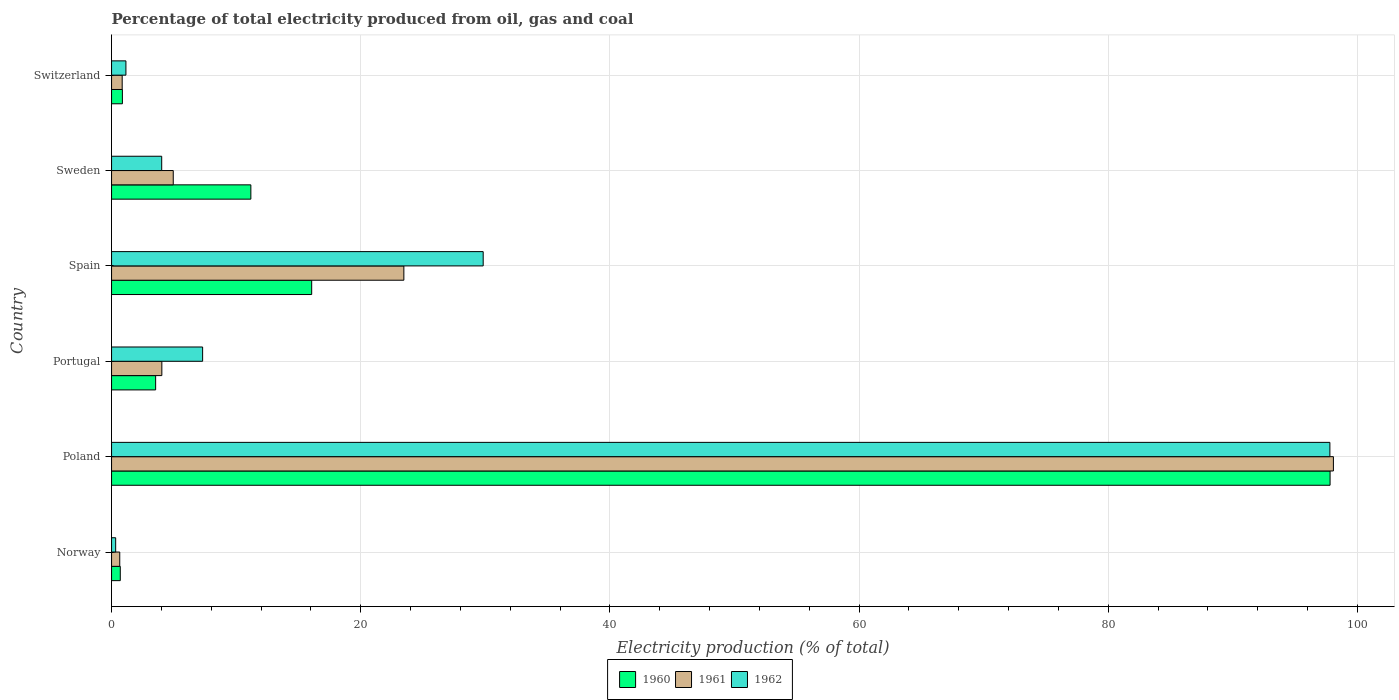Are the number of bars on each tick of the Y-axis equal?
Provide a short and direct response. Yes. How many bars are there on the 5th tick from the bottom?
Your answer should be very brief. 3. What is the label of the 2nd group of bars from the top?
Provide a short and direct response. Sweden. In how many cases, is the number of bars for a given country not equal to the number of legend labels?
Your answer should be compact. 0. What is the electricity production in in 1962 in Norway?
Provide a succinct answer. 0.33. Across all countries, what is the maximum electricity production in in 1961?
Keep it short and to the point. 98.07. Across all countries, what is the minimum electricity production in in 1960?
Your answer should be very brief. 0.7. In which country was the electricity production in in 1960 minimum?
Provide a succinct answer. Norway. What is the total electricity production in in 1962 in the graph?
Your answer should be very brief. 140.43. What is the difference between the electricity production in in 1962 in Sweden and that in Switzerland?
Your answer should be compact. 2.87. What is the difference between the electricity production in in 1962 in Switzerland and the electricity production in in 1960 in Portugal?
Provide a short and direct response. -2.38. What is the average electricity production in in 1962 per country?
Ensure brevity in your answer.  23.41. What is the difference between the electricity production in in 1961 and electricity production in in 1960 in Sweden?
Your answer should be very brief. -6.23. What is the ratio of the electricity production in in 1961 in Norway to that in Spain?
Provide a succinct answer. 0.03. Is the electricity production in in 1961 in Norway less than that in Spain?
Provide a short and direct response. Yes. What is the difference between the highest and the second highest electricity production in in 1960?
Your answer should be compact. 81.74. What is the difference between the highest and the lowest electricity production in in 1961?
Offer a very short reply. 97.41. In how many countries, is the electricity production in in 1961 greater than the average electricity production in in 1961 taken over all countries?
Offer a terse response. 2. Is the sum of the electricity production in in 1961 in Portugal and Sweden greater than the maximum electricity production in in 1960 across all countries?
Your response must be concise. No. Is it the case that in every country, the sum of the electricity production in in 1961 and electricity production in in 1962 is greater than the electricity production in in 1960?
Offer a very short reply. No. How many bars are there?
Provide a short and direct response. 18. How many countries are there in the graph?
Give a very brief answer. 6. What is the difference between two consecutive major ticks on the X-axis?
Ensure brevity in your answer.  20. How are the legend labels stacked?
Keep it short and to the point. Horizontal. What is the title of the graph?
Your response must be concise. Percentage of total electricity produced from oil, gas and coal. Does "1961" appear as one of the legend labels in the graph?
Offer a terse response. Yes. What is the label or title of the X-axis?
Your answer should be very brief. Electricity production (% of total). What is the Electricity production (% of total) of 1960 in Norway?
Give a very brief answer. 0.7. What is the Electricity production (% of total) in 1961 in Norway?
Provide a succinct answer. 0.66. What is the Electricity production (% of total) of 1962 in Norway?
Your answer should be very brief. 0.33. What is the Electricity production (% of total) in 1960 in Poland?
Give a very brief answer. 97.8. What is the Electricity production (% of total) of 1961 in Poland?
Your response must be concise. 98.07. What is the Electricity production (% of total) in 1962 in Poland?
Offer a terse response. 97.79. What is the Electricity production (% of total) of 1960 in Portugal?
Offer a very short reply. 3.54. What is the Electricity production (% of total) in 1961 in Portugal?
Keep it short and to the point. 4.04. What is the Electricity production (% of total) in 1962 in Portugal?
Your answer should be very brief. 7.31. What is the Electricity production (% of total) of 1960 in Spain?
Provide a short and direct response. 16.06. What is the Electricity production (% of total) of 1961 in Spain?
Your answer should be very brief. 23.46. What is the Electricity production (% of total) in 1962 in Spain?
Keep it short and to the point. 29.83. What is the Electricity production (% of total) in 1960 in Sweden?
Make the answer very short. 11.18. What is the Electricity production (% of total) in 1961 in Sweden?
Offer a terse response. 4.95. What is the Electricity production (% of total) of 1962 in Sweden?
Offer a terse response. 4.02. What is the Electricity production (% of total) of 1960 in Switzerland?
Your response must be concise. 0.87. What is the Electricity production (% of total) of 1961 in Switzerland?
Ensure brevity in your answer.  0.85. What is the Electricity production (% of total) of 1962 in Switzerland?
Keep it short and to the point. 1.15. Across all countries, what is the maximum Electricity production (% of total) in 1960?
Offer a very short reply. 97.8. Across all countries, what is the maximum Electricity production (% of total) in 1961?
Your answer should be compact. 98.07. Across all countries, what is the maximum Electricity production (% of total) in 1962?
Your response must be concise. 97.79. Across all countries, what is the minimum Electricity production (% of total) in 1960?
Ensure brevity in your answer.  0.7. Across all countries, what is the minimum Electricity production (% of total) of 1961?
Provide a succinct answer. 0.66. Across all countries, what is the minimum Electricity production (% of total) of 1962?
Your answer should be very brief. 0.33. What is the total Electricity production (% of total) of 1960 in the graph?
Offer a terse response. 130.15. What is the total Electricity production (% of total) in 1961 in the graph?
Keep it short and to the point. 132.03. What is the total Electricity production (% of total) of 1962 in the graph?
Provide a succinct answer. 140.43. What is the difference between the Electricity production (% of total) of 1960 in Norway and that in Poland?
Give a very brief answer. -97.1. What is the difference between the Electricity production (% of total) in 1961 in Norway and that in Poland?
Offer a terse response. -97.41. What is the difference between the Electricity production (% of total) in 1962 in Norway and that in Poland?
Keep it short and to the point. -97.46. What is the difference between the Electricity production (% of total) in 1960 in Norway and that in Portugal?
Your answer should be very brief. -2.84. What is the difference between the Electricity production (% of total) in 1961 in Norway and that in Portugal?
Your answer should be very brief. -3.38. What is the difference between the Electricity production (% of total) in 1962 in Norway and that in Portugal?
Provide a succinct answer. -6.98. What is the difference between the Electricity production (% of total) of 1960 in Norway and that in Spain?
Your answer should be very brief. -15.36. What is the difference between the Electricity production (% of total) in 1961 in Norway and that in Spain?
Provide a short and direct response. -22.8. What is the difference between the Electricity production (% of total) of 1962 in Norway and that in Spain?
Provide a short and direct response. -29.5. What is the difference between the Electricity production (% of total) in 1960 in Norway and that in Sweden?
Your answer should be compact. -10.48. What is the difference between the Electricity production (% of total) of 1961 in Norway and that in Sweden?
Your response must be concise. -4.29. What is the difference between the Electricity production (% of total) of 1962 in Norway and that in Sweden?
Your answer should be very brief. -3.69. What is the difference between the Electricity production (% of total) in 1960 in Norway and that in Switzerland?
Keep it short and to the point. -0.17. What is the difference between the Electricity production (% of total) of 1961 in Norway and that in Switzerland?
Make the answer very short. -0.2. What is the difference between the Electricity production (% of total) in 1962 in Norway and that in Switzerland?
Provide a succinct answer. -0.82. What is the difference between the Electricity production (% of total) of 1960 in Poland and that in Portugal?
Make the answer very short. 94.26. What is the difference between the Electricity production (% of total) in 1961 in Poland and that in Portugal?
Give a very brief answer. 94.03. What is the difference between the Electricity production (% of total) in 1962 in Poland and that in Portugal?
Provide a succinct answer. 90.48. What is the difference between the Electricity production (% of total) in 1960 in Poland and that in Spain?
Provide a succinct answer. 81.74. What is the difference between the Electricity production (% of total) of 1961 in Poland and that in Spain?
Ensure brevity in your answer.  74.61. What is the difference between the Electricity production (% of total) in 1962 in Poland and that in Spain?
Provide a short and direct response. 67.96. What is the difference between the Electricity production (% of total) of 1960 in Poland and that in Sweden?
Make the answer very short. 86.62. What is the difference between the Electricity production (% of total) in 1961 in Poland and that in Sweden?
Your response must be concise. 93.12. What is the difference between the Electricity production (% of total) in 1962 in Poland and that in Sweden?
Your response must be concise. 93.76. What is the difference between the Electricity production (% of total) of 1960 in Poland and that in Switzerland?
Offer a terse response. 96.93. What is the difference between the Electricity production (% of total) in 1961 in Poland and that in Switzerland?
Your response must be concise. 97.21. What is the difference between the Electricity production (% of total) of 1962 in Poland and that in Switzerland?
Your answer should be very brief. 96.63. What is the difference between the Electricity production (% of total) of 1960 in Portugal and that in Spain?
Offer a terse response. -12.53. What is the difference between the Electricity production (% of total) in 1961 in Portugal and that in Spain?
Offer a terse response. -19.42. What is the difference between the Electricity production (% of total) in 1962 in Portugal and that in Spain?
Your response must be concise. -22.52. What is the difference between the Electricity production (% of total) of 1960 in Portugal and that in Sweden?
Your answer should be very brief. -7.64. What is the difference between the Electricity production (% of total) of 1961 in Portugal and that in Sweden?
Provide a short and direct response. -0.92. What is the difference between the Electricity production (% of total) in 1962 in Portugal and that in Sweden?
Ensure brevity in your answer.  3.28. What is the difference between the Electricity production (% of total) in 1960 in Portugal and that in Switzerland?
Offer a terse response. 2.67. What is the difference between the Electricity production (% of total) of 1961 in Portugal and that in Switzerland?
Give a very brief answer. 3.18. What is the difference between the Electricity production (% of total) in 1962 in Portugal and that in Switzerland?
Your response must be concise. 6.16. What is the difference between the Electricity production (% of total) of 1960 in Spain and that in Sweden?
Offer a very short reply. 4.88. What is the difference between the Electricity production (% of total) in 1961 in Spain and that in Sweden?
Your answer should be very brief. 18.51. What is the difference between the Electricity production (% of total) in 1962 in Spain and that in Sweden?
Give a very brief answer. 25.8. What is the difference between the Electricity production (% of total) of 1960 in Spain and that in Switzerland?
Make the answer very short. 15.19. What is the difference between the Electricity production (% of total) in 1961 in Spain and that in Switzerland?
Give a very brief answer. 22.61. What is the difference between the Electricity production (% of total) of 1962 in Spain and that in Switzerland?
Your answer should be very brief. 28.67. What is the difference between the Electricity production (% of total) of 1960 in Sweden and that in Switzerland?
Make the answer very short. 10.31. What is the difference between the Electricity production (% of total) of 1961 in Sweden and that in Switzerland?
Provide a short and direct response. 4.1. What is the difference between the Electricity production (% of total) of 1962 in Sweden and that in Switzerland?
Provide a succinct answer. 2.87. What is the difference between the Electricity production (% of total) in 1960 in Norway and the Electricity production (% of total) in 1961 in Poland?
Give a very brief answer. -97.37. What is the difference between the Electricity production (% of total) of 1960 in Norway and the Electricity production (% of total) of 1962 in Poland?
Offer a terse response. -97.09. What is the difference between the Electricity production (% of total) of 1961 in Norway and the Electricity production (% of total) of 1962 in Poland?
Give a very brief answer. -97.13. What is the difference between the Electricity production (% of total) in 1960 in Norway and the Electricity production (% of total) in 1961 in Portugal?
Ensure brevity in your answer.  -3.34. What is the difference between the Electricity production (% of total) in 1960 in Norway and the Electricity production (% of total) in 1962 in Portugal?
Provide a short and direct response. -6.61. What is the difference between the Electricity production (% of total) of 1961 in Norway and the Electricity production (% of total) of 1962 in Portugal?
Your answer should be very brief. -6.65. What is the difference between the Electricity production (% of total) of 1960 in Norway and the Electricity production (% of total) of 1961 in Spain?
Provide a short and direct response. -22.76. What is the difference between the Electricity production (% of total) in 1960 in Norway and the Electricity production (% of total) in 1962 in Spain?
Offer a very short reply. -29.13. What is the difference between the Electricity production (% of total) in 1961 in Norway and the Electricity production (% of total) in 1962 in Spain?
Make the answer very short. -29.17. What is the difference between the Electricity production (% of total) of 1960 in Norway and the Electricity production (% of total) of 1961 in Sweden?
Offer a very short reply. -4.25. What is the difference between the Electricity production (% of total) in 1960 in Norway and the Electricity production (% of total) in 1962 in Sweden?
Your response must be concise. -3.33. What is the difference between the Electricity production (% of total) in 1961 in Norway and the Electricity production (% of total) in 1962 in Sweden?
Ensure brevity in your answer.  -3.37. What is the difference between the Electricity production (% of total) in 1960 in Norway and the Electricity production (% of total) in 1961 in Switzerland?
Give a very brief answer. -0.15. What is the difference between the Electricity production (% of total) in 1960 in Norway and the Electricity production (% of total) in 1962 in Switzerland?
Your answer should be very brief. -0.45. What is the difference between the Electricity production (% of total) in 1961 in Norway and the Electricity production (% of total) in 1962 in Switzerland?
Your answer should be very brief. -0.5. What is the difference between the Electricity production (% of total) of 1960 in Poland and the Electricity production (% of total) of 1961 in Portugal?
Keep it short and to the point. 93.76. What is the difference between the Electricity production (% of total) in 1960 in Poland and the Electricity production (% of total) in 1962 in Portugal?
Your answer should be very brief. 90.49. What is the difference between the Electricity production (% of total) in 1961 in Poland and the Electricity production (% of total) in 1962 in Portugal?
Give a very brief answer. 90.76. What is the difference between the Electricity production (% of total) in 1960 in Poland and the Electricity production (% of total) in 1961 in Spain?
Provide a succinct answer. 74.34. What is the difference between the Electricity production (% of total) of 1960 in Poland and the Electricity production (% of total) of 1962 in Spain?
Give a very brief answer. 67.97. What is the difference between the Electricity production (% of total) in 1961 in Poland and the Electricity production (% of total) in 1962 in Spain?
Your answer should be very brief. 68.24. What is the difference between the Electricity production (% of total) of 1960 in Poland and the Electricity production (% of total) of 1961 in Sweden?
Offer a very short reply. 92.85. What is the difference between the Electricity production (% of total) in 1960 in Poland and the Electricity production (% of total) in 1962 in Sweden?
Offer a very short reply. 93.78. What is the difference between the Electricity production (% of total) in 1961 in Poland and the Electricity production (% of total) in 1962 in Sweden?
Your response must be concise. 94.04. What is the difference between the Electricity production (% of total) of 1960 in Poland and the Electricity production (% of total) of 1961 in Switzerland?
Give a very brief answer. 96.95. What is the difference between the Electricity production (% of total) of 1960 in Poland and the Electricity production (% of total) of 1962 in Switzerland?
Give a very brief answer. 96.65. What is the difference between the Electricity production (% of total) in 1961 in Poland and the Electricity production (% of total) in 1962 in Switzerland?
Give a very brief answer. 96.91. What is the difference between the Electricity production (% of total) in 1960 in Portugal and the Electricity production (% of total) in 1961 in Spain?
Provide a succinct answer. -19.92. What is the difference between the Electricity production (% of total) in 1960 in Portugal and the Electricity production (% of total) in 1962 in Spain?
Provide a succinct answer. -26.29. What is the difference between the Electricity production (% of total) of 1961 in Portugal and the Electricity production (% of total) of 1962 in Spain?
Offer a terse response. -25.79. What is the difference between the Electricity production (% of total) in 1960 in Portugal and the Electricity production (% of total) in 1961 in Sweden?
Make the answer very short. -1.41. What is the difference between the Electricity production (% of total) of 1960 in Portugal and the Electricity production (% of total) of 1962 in Sweden?
Provide a succinct answer. -0.49. What is the difference between the Electricity production (% of total) in 1961 in Portugal and the Electricity production (% of total) in 1962 in Sweden?
Provide a succinct answer. 0.01. What is the difference between the Electricity production (% of total) in 1960 in Portugal and the Electricity production (% of total) in 1961 in Switzerland?
Keep it short and to the point. 2.68. What is the difference between the Electricity production (% of total) in 1960 in Portugal and the Electricity production (% of total) in 1962 in Switzerland?
Provide a short and direct response. 2.38. What is the difference between the Electricity production (% of total) in 1961 in Portugal and the Electricity production (% of total) in 1962 in Switzerland?
Give a very brief answer. 2.88. What is the difference between the Electricity production (% of total) in 1960 in Spain and the Electricity production (% of total) in 1961 in Sweden?
Your response must be concise. 11.11. What is the difference between the Electricity production (% of total) in 1960 in Spain and the Electricity production (% of total) in 1962 in Sweden?
Your answer should be compact. 12.04. What is the difference between the Electricity production (% of total) of 1961 in Spain and the Electricity production (% of total) of 1962 in Sweden?
Offer a very short reply. 19.44. What is the difference between the Electricity production (% of total) in 1960 in Spain and the Electricity production (% of total) in 1961 in Switzerland?
Make the answer very short. 15.21. What is the difference between the Electricity production (% of total) of 1960 in Spain and the Electricity production (% of total) of 1962 in Switzerland?
Make the answer very short. 14.91. What is the difference between the Electricity production (% of total) of 1961 in Spain and the Electricity production (% of total) of 1962 in Switzerland?
Your answer should be very brief. 22.31. What is the difference between the Electricity production (% of total) in 1960 in Sweden and the Electricity production (% of total) in 1961 in Switzerland?
Your answer should be very brief. 10.33. What is the difference between the Electricity production (% of total) of 1960 in Sweden and the Electricity production (% of total) of 1962 in Switzerland?
Make the answer very short. 10.03. What is the difference between the Electricity production (% of total) in 1961 in Sweden and the Electricity production (% of total) in 1962 in Switzerland?
Keep it short and to the point. 3.8. What is the average Electricity production (% of total) in 1960 per country?
Keep it short and to the point. 21.69. What is the average Electricity production (% of total) in 1961 per country?
Provide a short and direct response. 22. What is the average Electricity production (% of total) of 1962 per country?
Your response must be concise. 23.41. What is the difference between the Electricity production (% of total) in 1960 and Electricity production (% of total) in 1961 in Norway?
Your response must be concise. 0.04. What is the difference between the Electricity production (% of total) of 1960 and Electricity production (% of total) of 1962 in Norway?
Keep it short and to the point. 0.37. What is the difference between the Electricity production (% of total) of 1961 and Electricity production (% of total) of 1962 in Norway?
Ensure brevity in your answer.  0.33. What is the difference between the Electricity production (% of total) of 1960 and Electricity production (% of total) of 1961 in Poland?
Make the answer very short. -0.27. What is the difference between the Electricity production (% of total) of 1960 and Electricity production (% of total) of 1962 in Poland?
Offer a terse response. 0.01. What is the difference between the Electricity production (% of total) of 1961 and Electricity production (% of total) of 1962 in Poland?
Provide a short and direct response. 0.28. What is the difference between the Electricity production (% of total) of 1960 and Electricity production (% of total) of 1961 in Portugal?
Ensure brevity in your answer.  -0.5. What is the difference between the Electricity production (% of total) in 1960 and Electricity production (% of total) in 1962 in Portugal?
Your response must be concise. -3.77. What is the difference between the Electricity production (% of total) of 1961 and Electricity production (% of total) of 1962 in Portugal?
Your answer should be compact. -3.27. What is the difference between the Electricity production (% of total) in 1960 and Electricity production (% of total) in 1961 in Spain?
Provide a succinct answer. -7.4. What is the difference between the Electricity production (% of total) in 1960 and Electricity production (% of total) in 1962 in Spain?
Offer a terse response. -13.76. What is the difference between the Electricity production (% of total) of 1961 and Electricity production (% of total) of 1962 in Spain?
Offer a very short reply. -6.37. What is the difference between the Electricity production (% of total) of 1960 and Electricity production (% of total) of 1961 in Sweden?
Offer a very short reply. 6.23. What is the difference between the Electricity production (% of total) in 1960 and Electricity production (% of total) in 1962 in Sweden?
Your answer should be very brief. 7.16. What is the difference between the Electricity production (% of total) of 1961 and Electricity production (% of total) of 1962 in Sweden?
Your answer should be compact. 0.93. What is the difference between the Electricity production (% of total) in 1960 and Electricity production (% of total) in 1961 in Switzerland?
Keep it short and to the point. 0.02. What is the difference between the Electricity production (% of total) in 1960 and Electricity production (% of total) in 1962 in Switzerland?
Provide a succinct answer. -0.28. What is the difference between the Electricity production (% of total) of 1961 and Electricity production (% of total) of 1962 in Switzerland?
Your answer should be very brief. -0.3. What is the ratio of the Electricity production (% of total) in 1960 in Norway to that in Poland?
Provide a succinct answer. 0.01. What is the ratio of the Electricity production (% of total) of 1961 in Norway to that in Poland?
Ensure brevity in your answer.  0.01. What is the ratio of the Electricity production (% of total) in 1962 in Norway to that in Poland?
Give a very brief answer. 0. What is the ratio of the Electricity production (% of total) in 1960 in Norway to that in Portugal?
Offer a terse response. 0.2. What is the ratio of the Electricity production (% of total) in 1961 in Norway to that in Portugal?
Keep it short and to the point. 0.16. What is the ratio of the Electricity production (% of total) in 1962 in Norway to that in Portugal?
Offer a terse response. 0.05. What is the ratio of the Electricity production (% of total) of 1960 in Norway to that in Spain?
Make the answer very short. 0.04. What is the ratio of the Electricity production (% of total) in 1961 in Norway to that in Spain?
Provide a succinct answer. 0.03. What is the ratio of the Electricity production (% of total) in 1962 in Norway to that in Spain?
Your answer should be very brief. 0.01. What is the ratio of the Electricity production (% of total) of 1960 in Norway to that in Sweden?
Give a very brief answer. 0.06. What is the ratio of the Electricity production (% of total) of 1961 in Norway to that in Sweden?
Provide a short and direct response. 0.13. What is the ratio of the Electricity production (% of total) in 1962 in Norway to that in Sweden?
Your response must be concise. 0.08. What is the ratio of the Electricity production (% of total) of 1960 in Norway to that in Switzerland?
Your answer should be compact. 0.8. What is the ratio of the Electricity production (% of total) in 1961 in Norway to that in Switzerland?
Provide a short and direct response. 0.77. What is the ratio of the Electricity production (% of total) in 1962 in Norway to that in Switzerland?
Provide a succinct answer. 0.29. What is the ratio of the Electricity production (% of total) of 1960 in Poland to that in Portugal?
Your response must be concise. 27.65. What is the ratio of the Electricity production (% of total) of 1961 in Poland to that in Portugal?
Offer a very short reply. 24.3. What is the ratio of the Electricity production (% of total) of 1962 in Poland to that in Portugal?
Offer a terse response. 13.38. What is the ratio of the Electricity production (% of total) of 1960 in Poland to that in Spain?
Ensure brevity in your answer.  6.09. What is the ratio of the Electricity production (% of total) of 1961 in Poland to that in Spain?
Ensure brevity in your answer.  4.18. What is the ratio of the Electricity production (% of total) in 1962 in Poland to that in Spain?
Offer a terse response. 3.28. What is the ratio of the Electricity production (% of total) in 1960 in Poland to that in Sweden?
Provide a short and direct response. 8.75. What is the ratio of the Electricity production (% of total) in 1961 in Poland to that in Sweden?
Provide a short and direct response. 19.8. What is the ratio of the Electricity production (% of total) of 1962 in Poland to that in Sweden?
Your answer should be very brief. 24.3. What is the ratio of the Electricity production (% of total) of 1960 in Poland to that in Switzerland?
Provide a short and direct response. 112.47. What is the ratio of the Electricity production (% of total) in 1961 in Poland to that in Switzerland?
Ensure brevity in your answer.  114.89. What is the ratio of the Electricity production (% of total) in 1962 in Poland to that in Switzerland?
Offer a terse response. 84.78. What is the ratio of the Electricity production (% of total) in 1960 in Portugal to that in Spain?
Keep it short and to the point. 0.22. What is the ratio of the Electricity production (% of total) in 1961 in Portugal to that in Spain?
Offer a terse response. 0.17. What is the ratio of the Electricity production (% of total) in 1962 in Portugal to that in Spain?
Provide a short and direct response. 0.24. What is the ratio of the Electricity production (% of total) in 1960 in Portugal to that in Sweden?
Make the answer very short. 0.32. What is the ratio of the Electricity production (% of total) of 1961 in Portugal to that in Sweden?
Ensure brevity in your answer.  0.82. What is the ratio of the Electricity production (% of total) in 1962 in Portugal to that in Sweden?
Give a very brief answer. 1.82. What is the ratio of the Electricity production (% of total) in 1960 in Portugal to that in Switzerland?
Make the answer very short. 4.07. What is the ratio of the Electricity production (% of total) of 1961 in Portugal to that in Switzerland?
Offer a terse response. 4.73. What is the ratio of the Electricity production (% of total) in 1962 in Portugal to that in Switzerland?
Your response must be concise. 6.34. What is the ratio of the Electricity production (% of total) of 1960 in Spain to that in Sweden?
Ensure brevity in your answer.  1.44. What is the ratio of the Electricity production (% of total) of 1961 in Spain to that in Sweden?
Offer a very short reply. 4.74. What is the ratio of the Electricity production (% of total) of 1962 in Spain to that in Sweden?
Keep it short and to the point. 7.41. What is the ratio of the Electricity production (% of total) in 1960 in Spain to that in Switzerland?
Your response must be concise. 18.47. What is the ratio of the Electricity production (% of total) of 1961 in Spain to that in Switzerland?
Your answer should be very brief. 27.48. What is the ratio of the Electricity production (% of total) of 1962 in Spain to that in Switzerland?
Make the answer very short. 25.86. What is the ratio of the Electricity production (% of total) in 1960 in Sweden to that in Switzerland?
Offer a very short reply. 12.86. What is the ratio of the Electricity production (% of total) in 1961 in Sweden to that in Switzerland?
Provide a short and direct response. 5.8. What is the ratio of the Electricity production (% of total) in 1962 in Sweden to that in Switzerland?
Your answer should be compact. 3.49. What is the difference between the highest and the second highest Electricity production (% of total) in 1960?
Give a very brief answer. 81.74. What is the difference between the highest and the second highest Electricity production (% of total) of 1961?
Your answer should be very brief. 74.61. What is the difference between the highest and the second highest Electricity production (% of total) of 1962?
Provide a succinct answer. 67.96. What is the difference between the highest and the lowest Electricity production (% of total) in 1960?
Keep it short and to the point. 97.1. What is the difference between the highest and the lowest Electricity production (% of total) in 1961?
Provide a succinct answer. 97.41. What is the difference between the highest and the lowest Electricity production (% of total) of 1962?
Keep it short and to the point. 97.46. 